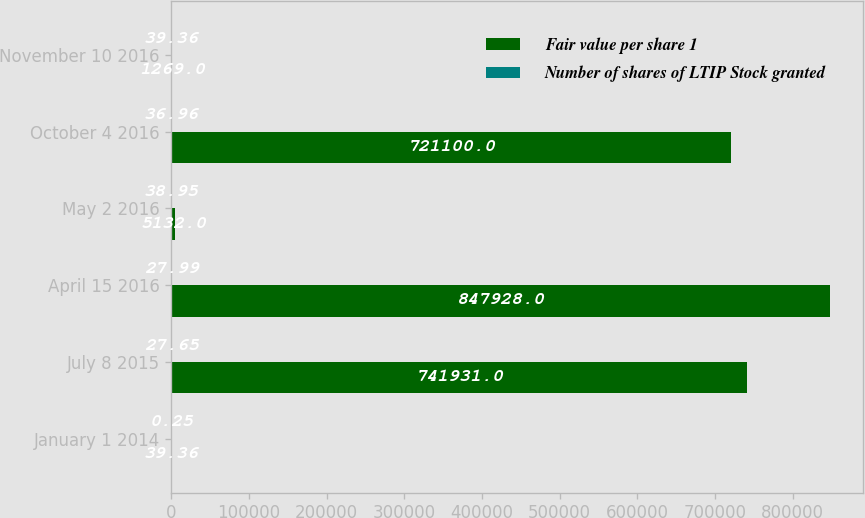<chart> <loc_0><loc_0><loc_500><loc_500><stacked_bar_chart><ecel><fcel>January 1 2014<fcel>July 8 2015<fcel>April 15 2016<fcel>May 2 2016<fcel>October 4 2016<fcel>November 10 2016<nl><fcel>Fair value per share 1<fcel>39.36<fcel>741931<fcel>847928<fcel>5132<fcel>721100<fcel>1269<nl><fcel>Number of shares of LTIP Stock granted<fcel>0.25<fcel>27.65<fcel>27.99<fcel>38.95<fcel>36.96<fcel>39.36<nl></chart> 